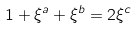<formula> <loc_0><loc_0><loc_500><loc_500>1 + \xi ^ { a } + \xi ^ { b } = 2 \xi ^ { c }</formula> 